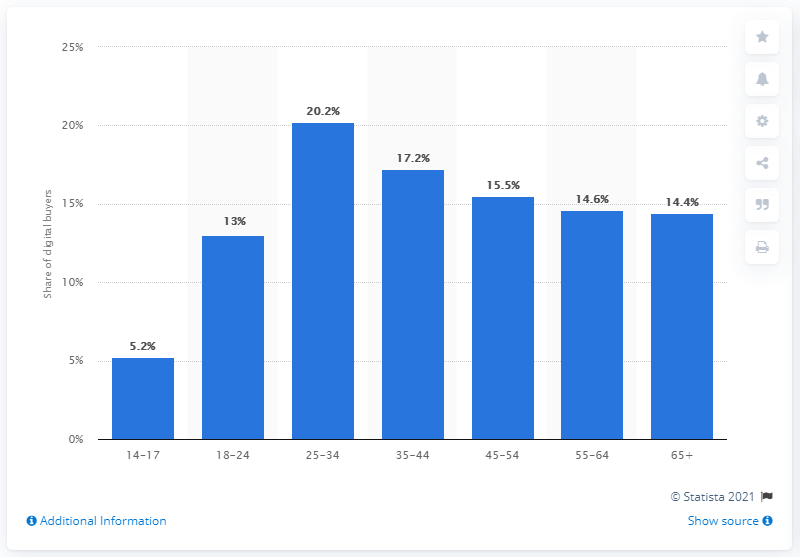Give some essential details in this illustration. As of February 2020, it was reported that 20.2% of digital buyers were Millennials. 